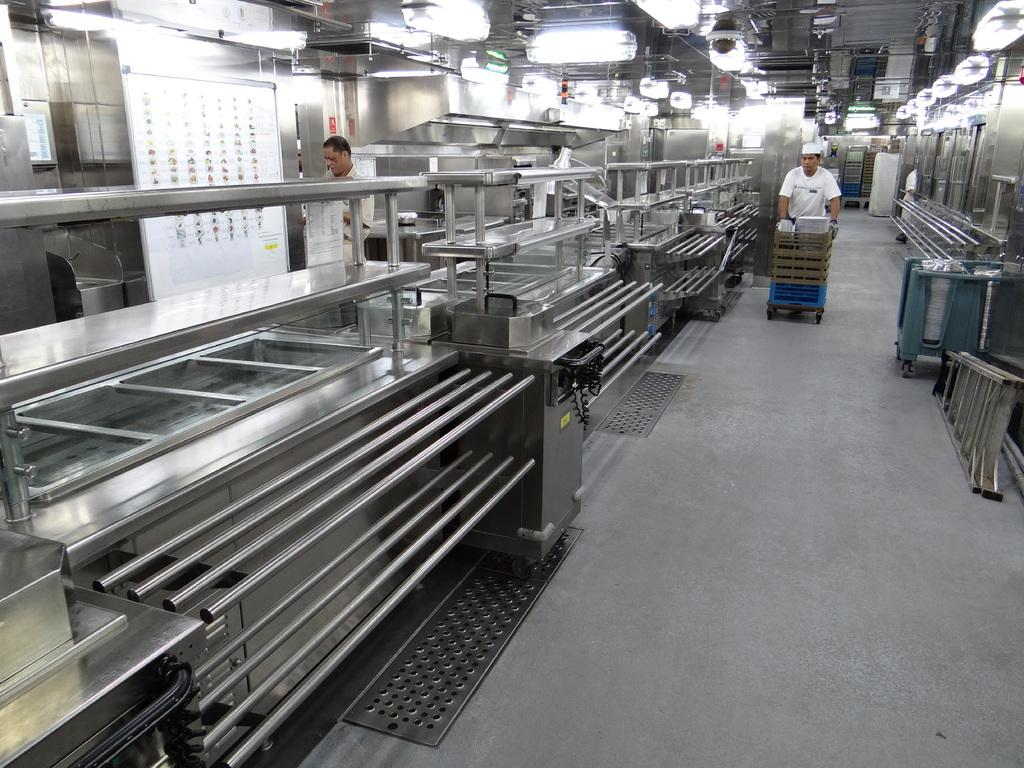What can be seen on the left side of the image? There are machines on the left side of the image. Can you describe the person in the image? There is a person in the image. What is the person doing in the image? The person is pulling a trolley. What type of milk is being used to water the yam plants in the image? There is no milk or yam plants present in the image. Is the person on holiday in the image? The provided facts do not mention anything about a holiday, so we cannot determine if the person is on holiday from the image. 